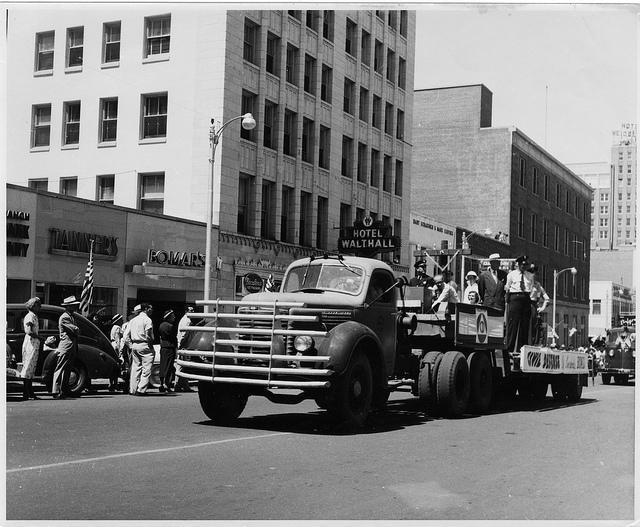How many trucks can you see?
Give a very brief answer. 1. 